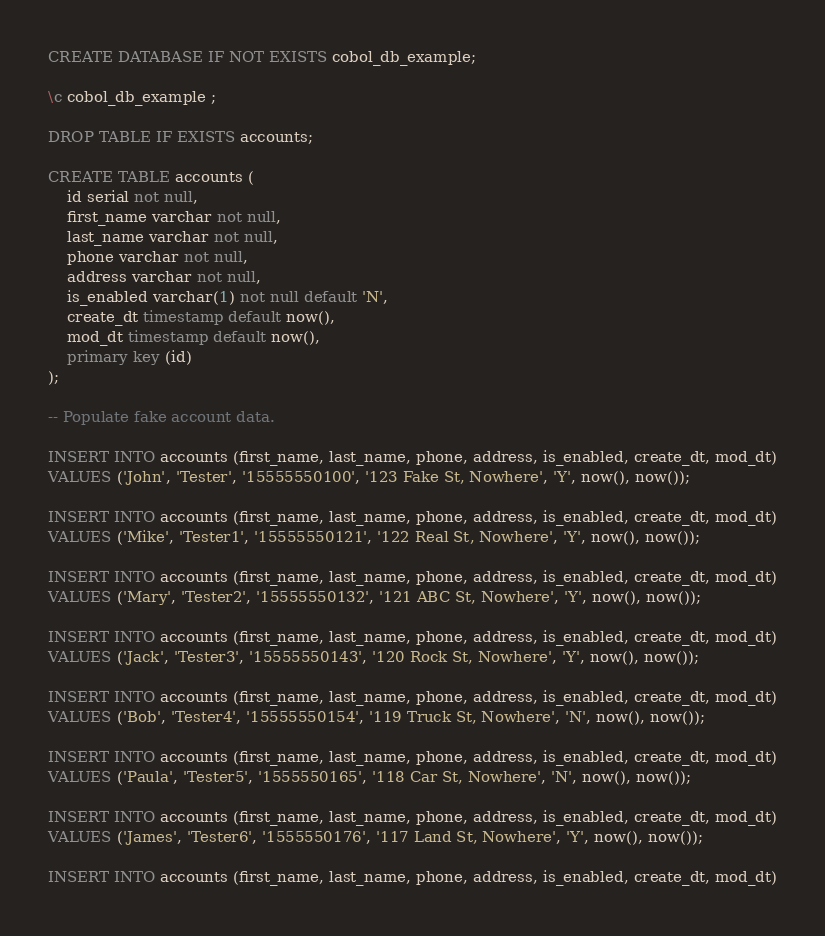<code> <loc_0><loc_0><loc_500><loc_500><_SQL_>
CREATE DATABASE IF NOT EXISTS cobol_db_example;

\c cobol_db_example ;

DROP TABLE IF EXISTS accounts;

CREATE TABLE accounts ( 
	id serial not null, 
	first_name varchar not null, 
	last_name varchar not null, 
	phone varchar not null, 
	address varchar not null, 
	is_enabled varchar(1) not null default 'N', 
	create_dt timestamp default now(), 
	mod_dt timestamp default now(), 
	primary key (id) 
);

-- Populate fake account data.

INSERT INTO accounts (first_name, last_name, phone, address, is_enabled, create_dt, mod_dt)
VALUES ('John', 'Tester', '15555550100', '123 Fake St, Nowhere', 'Y', now(), now());

INSERT INTO accounts (first_name, last_name, phone, address, is_enabled, create_dt, mod_dt)
VALUES ('Mike', 'Tester1', '15555550121', '122 Real St, Nowhere', 'Y', now(), now());

INSERT INTO accounts (first_name, last_name, phone, address, is_enabled, create_dt, mod_dt)
VALUES ('Mary', 'Tester2', '15555550132', '121 ABC St, Nowhere', 'Y', now(), now());

INSERT INTO accounts (first_name, last_name, phone, address, is_enabled, create_dt, mod_dt)
VALUES ('Jack', 'Tester3', '15555550143', '120 Rock St, Nowhere', 'Y', now(), now());

INSERT INTO accounts (first_name, last_name, phone, address, is_enabled, create_dt, mod_dt)
VALUES ('Bob', 'Tester4', '15555550154', '119 Truck St, Nowhere', 'N', now(), now());

INSERT INTO accounts (first_name, last_name, phone, address, is_enabled, create_dt, mod_dt)
VALUES ('Paula', 'Tester5', '1555550165', '118 Car St, Nowhere', 'N', now(), now());

INSERT INTO accounts (first_name, last_name, phone, address, is_enabled, create_dt, mod_dt)
VALUES ('James', 'Tester6', '1555550176', '117 Land St, Nowhere', 'Y', now(), now());

INSERT INTO accounts (first_name, last_name, phone, address, is_enabled, create_dt, mod_dt)</code> 